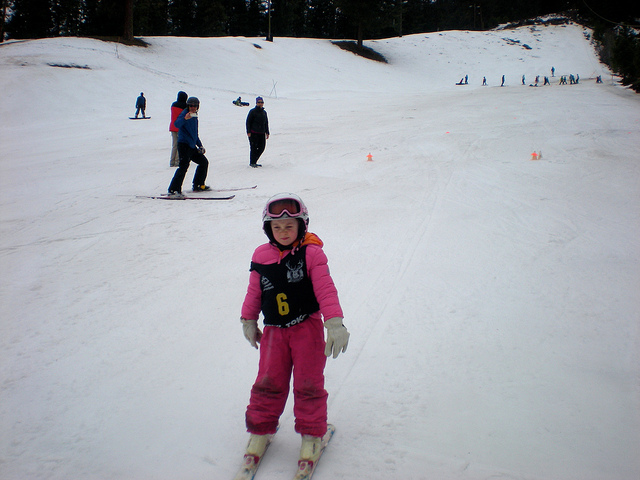Read and extract the text from this image. 011 TOK 6 